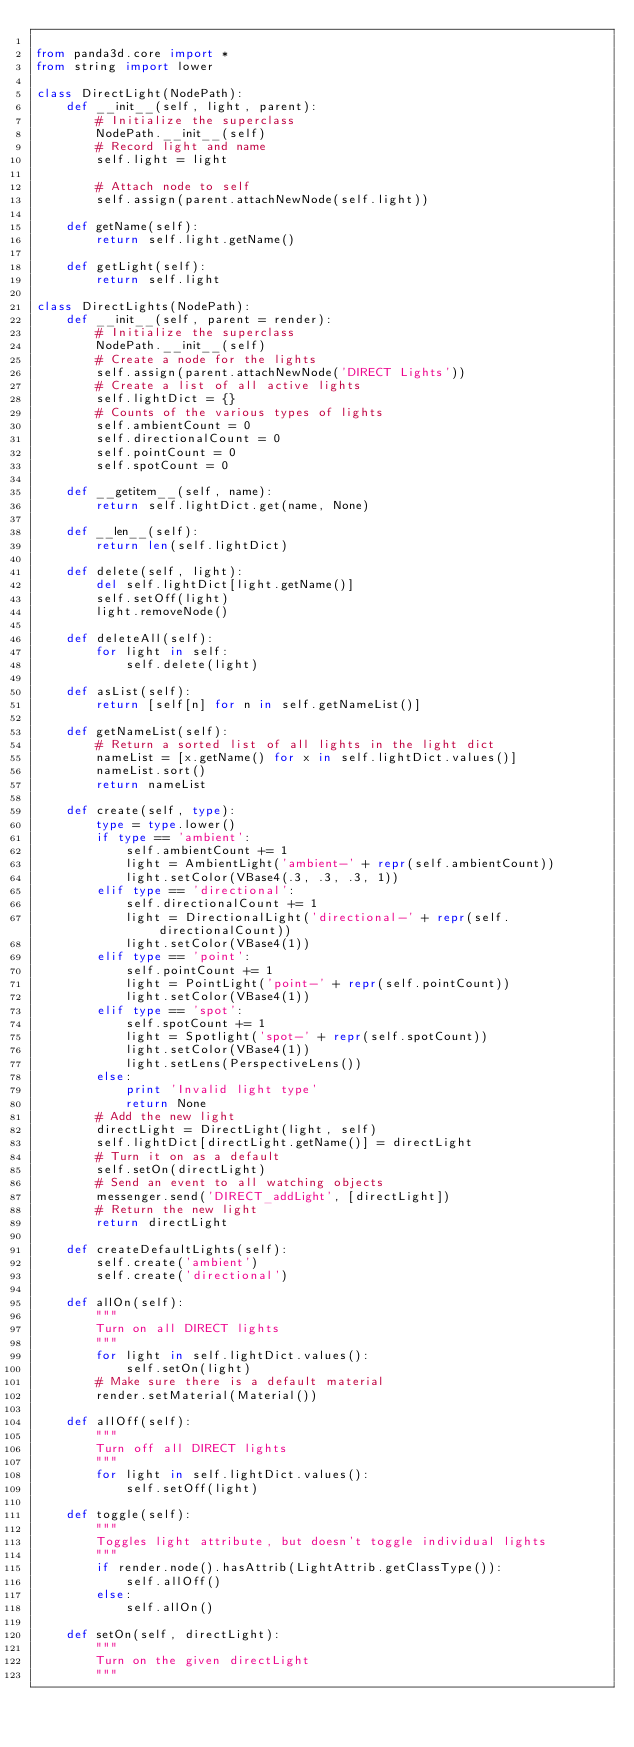<code> <loc_0><loc_0><loc_500><loc_500><_Python_>
from panda3d.core import *
from string import lower

class DirectLight(NodePath):
    def __init__(self, light, parent):
        # Initialize the superclass
        NodePath.__init__(self)
        # Record light and name
        self.light = light
        
        # Attach node to self
        self.assign(parent.attachNewNode(self.light))

    def getName(self):
        return self.light.getName()

    def getLight(self):
        return self.light

class DirectLights(NodePath):
    def __init__(self, parent = render):
        # Initialize the superclass
        NodePath.__init__(self)
        # Create a node for the lights
        self.assign(parent.attachNewNode('DIRECT Lights'))
        # Create a list of all active lights
        self.lightDict = {}
        # Counts of the various types of lights
        self.ambientCount = 0
        self.directionalCount = 0
        self.pointCount = 0
        self.spotCount = 0

    def __getitem__(self, name):
        return self.lightDict.get(name, None)

    def __len__(self):
        return len(self.lightDict)

    def delete(self, light):
        del self.lightDict[light.getName()]
        self.setOff(light)
        light.removeNode()

    def deleteAll(self):
        for light in self:
            self.delete(light)

    def asList(self):
        return [self[n] for n in self.getNameList()]

    def getNameList(self):
        # Return a sorted list of all lights in the light dict
        nameList = [x.getName() for x in self.lightDict.values()]
        nameList.sort()
        return nameList

    def create(self, type):
        type = type.lower()
        if type == 'ambient':
            self.ambientCount += 1
            light = AmbientLight('ambient-' + repr(self.ambientCount))
            light.setColor(VBase4(.3, .3, .3, 1))
        elif type == 'directional':
            self.directionalCount += 1
            light = DirectionalLight('directional-' + repr(self.directionalCount))
            light.setColor(VBase4(1))
        elif type == 'point':
            self.pointCount += 1
            light = PointLight('point-' + repr(self.pointCount))
            light.setColor(VBase4(1))
        elif type == 'spot':
            self.spotCount += 1
            light = Spotlight('spot-' + repr(self.spotCount))
            light.setColor(VBase4(1))
            light.setLens(PerspectiveLens())
        else:
            print 'Invalid light type'
            return None
        # Add the new light
        directLight = DirectLight(light, self)
        self.lightDict[directLight.getName()] = directLight
        # Turn it on as a default
        self.setOn(directLight)
        # Send an event to all watching objects
        messenger.send('DIRECT_addLight', [directLight])
        # Return the new light
        return directLight

    def createDefaultLights(self):
        self.create('ambient')
        self.create('directional')

    def allOn(self):
        """
        Turn on all DIRECT lights
        """
        for light in self.lightDict.values():
            self.setOn(light)
        # Make sure there is a default material
        render.setMaterial(Material())

    def allOff(self):
        """
        Turn off all DIRECT lights
        """
        for light in self.lightDict.values():
            self.setOff(light)

    def toggle(self):
        """
        Toggles light attribute, but doesn't toggle individual lights
        """
        if render.node().hasAttrib(LightAttrib.getClassType()):
            self.allOff()
        else:
            self.allOn()

    def setOn(self, directLight):
        """
        Turn on the given directLight
        """</code> 